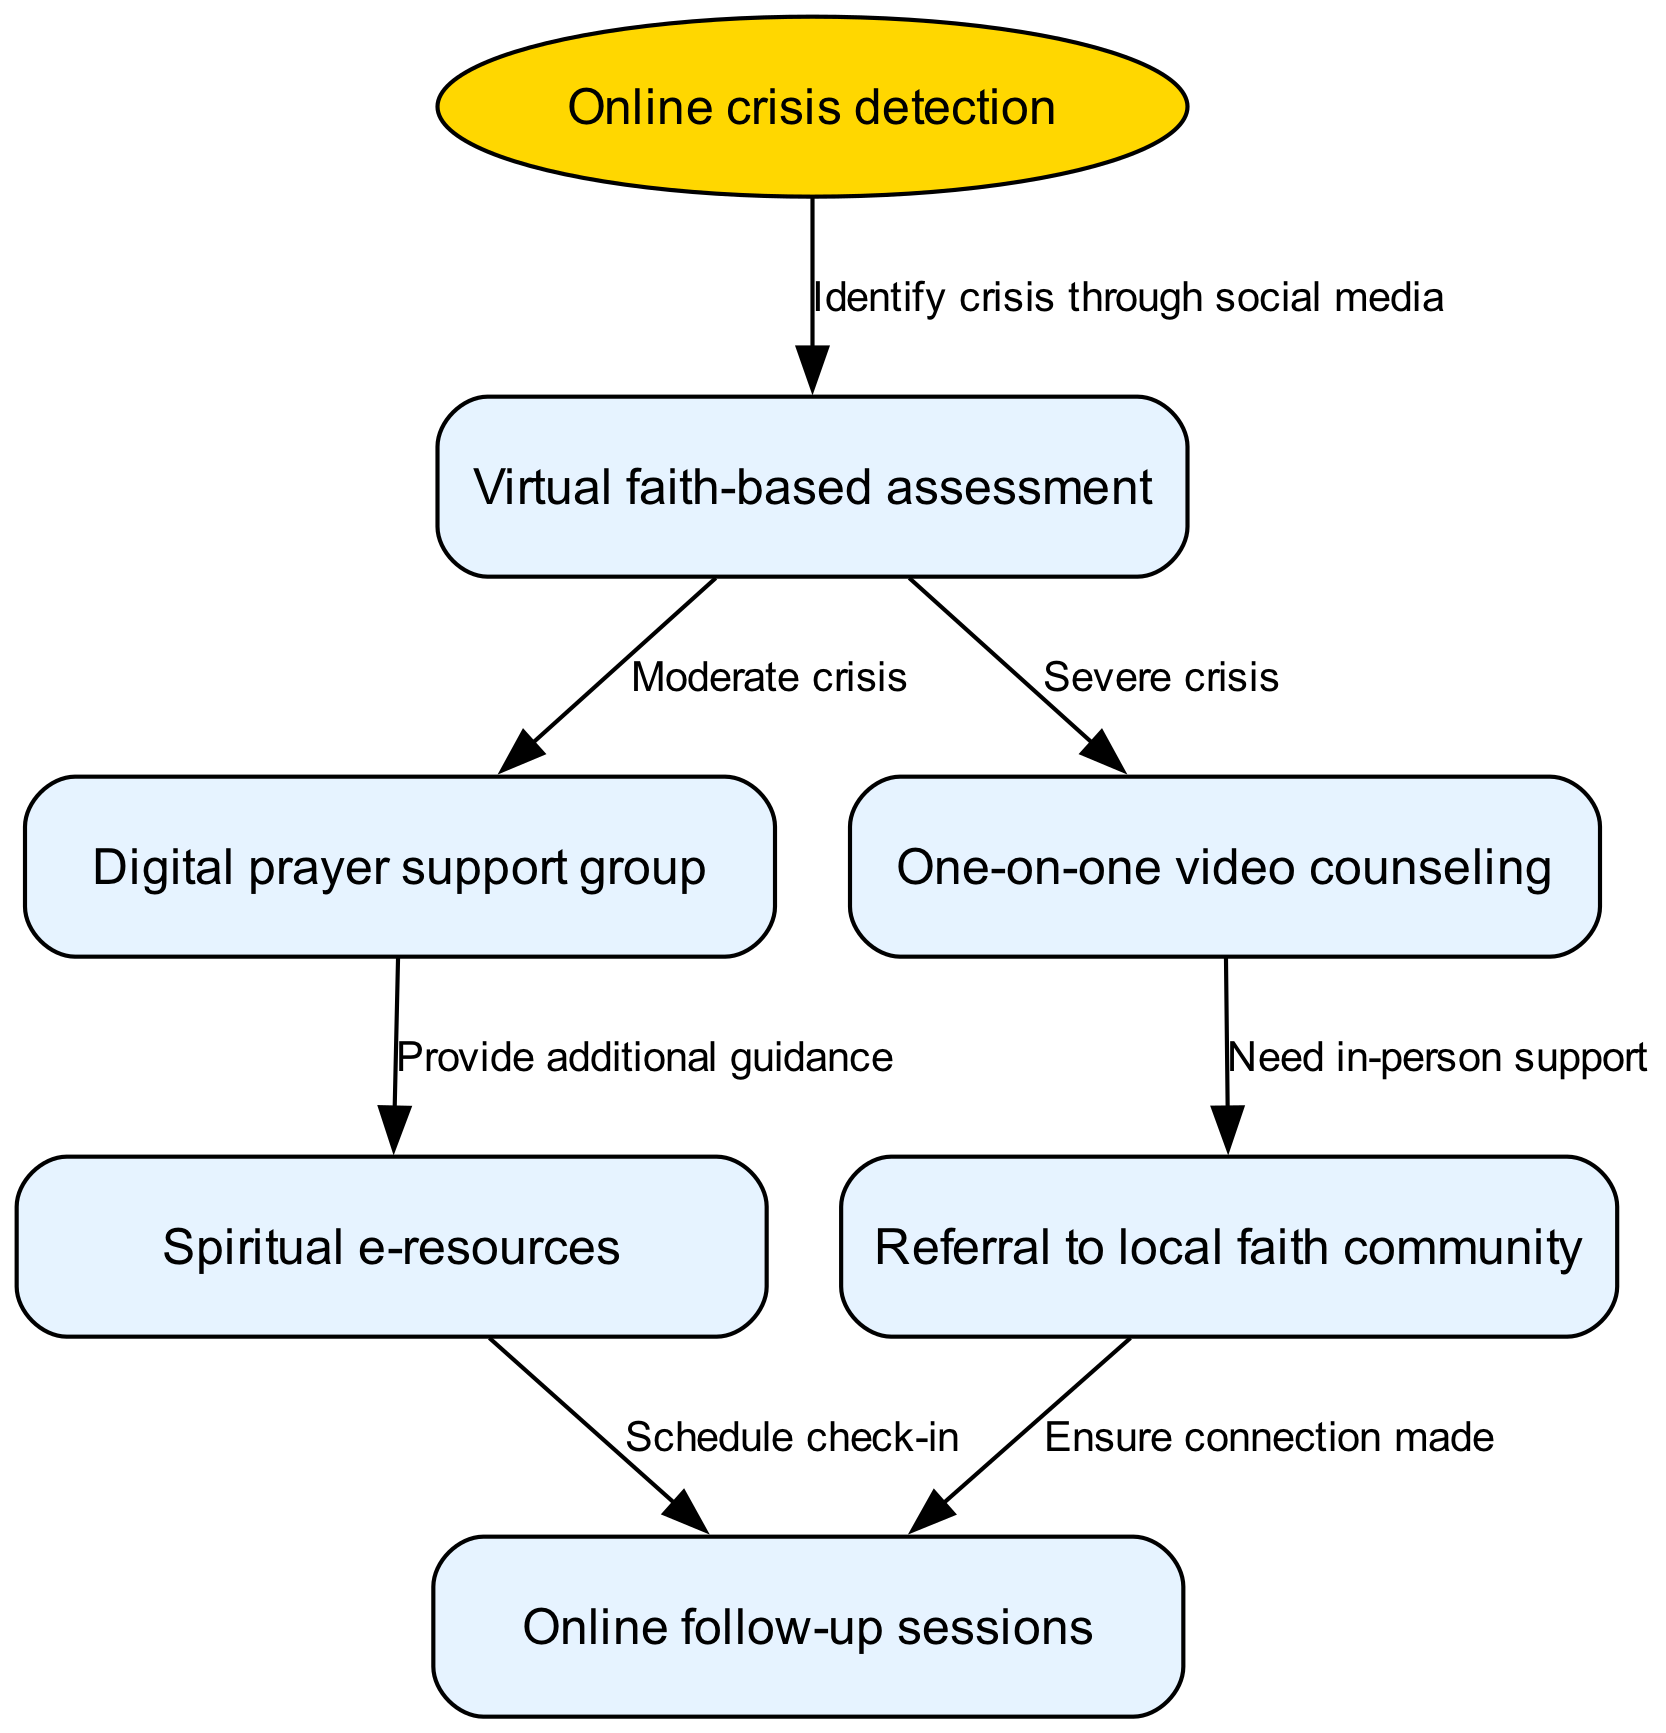What is the starting point of the pathway? The starting point, as indicated in the diagram, is labeled "Online crisis detection."
Answer: Online crisis detection How many nodes are in the diagram? By counting all the distinct nodes listed in the diagram, there are a total of six nodes: the starting point and five subsequent nodes.
Answer: 6 What are the edges that follow the "Virtual faith-based assessment" node? The edges that follow the "Virtual faith-based assessment" node connect to "Digital prayer support group" for moderate crises and "One-on-one video counseling" for severe crises.
Answer: Digital prayer support group, One-on-one video counseling Which node leads to "Referral to local faith community"? The node that leads to "Referral to local faith community" is "One-on-one video counseling" based on the edge defined in the diagram.
Answer: One-on-one video counseling What type of support is provided after the "Digital prayer support group"? Following the "Digital prayer support group," the type of support provided is "Spiritual e-resources" based on the flow shown in the diagram.
Answer: Spiritual e-resources What happens after providing "Spiritual e-resources"? After providing "Spiritual e-resources," it leads to the "Online follow-up sessions," which are scheduled as part of the continuous support pathway.
Answer: Online follow-up sessions What is the connection between "Referral to local faith community" and follow-up? The connection is established to ensure that the participant receives in-person support after being referred, leading to "Online follow-up sessions" to guarantee that the connection is made.
Answer: Ensure connection made If someone is in a "Moderate crisis," what is the next immediate step according to the diagram? The immediate next step for someone in a "Moderate crisis" would be to enter the "Digital prayer support group" as the directed flow suggests.
Answer: Digital prayer support group 